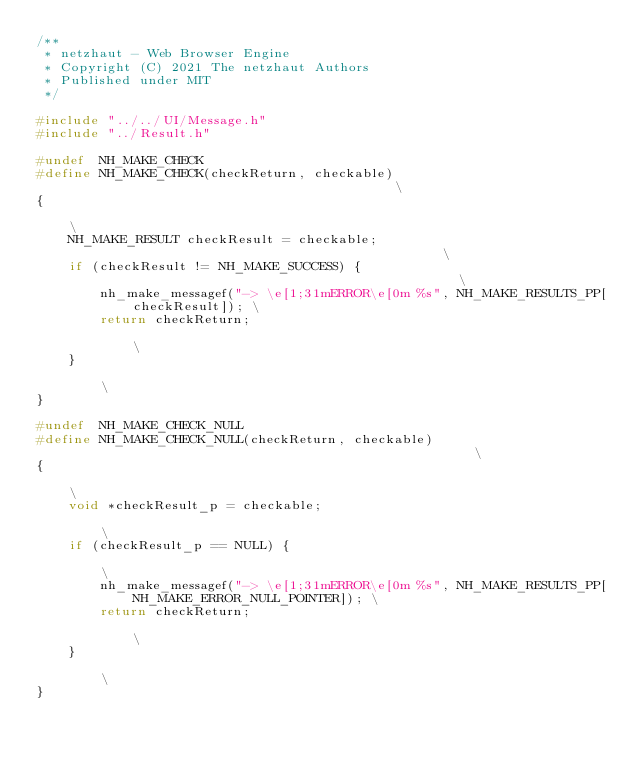Convert code to text. <code><loc_0><loc_0><loc_500><loc_500><_C_>/**
 * netzhaut - Web Browser Engine
 * Copyright (C) 2021 The netzhaut Authors
 * Published under MIT
 */

#include "../../UI/Message.h"
#include "../Result.h"

#undef  NH_MAKE_CHECK
#define NH_MAKE_CHECK(checkReturn, checkable)                                          \
{                                                                                      \
    NH_MAKE_RESULT checkResult = checkable;                                            \
    if (checkResult != NH_MAKE_SUCCESS) {                                              \
        nh_make_messagef("-> \e[1;31mERROR\e[0m %s", NH_MAKE_RESULTS_PP[checkResult]); \
        return checkReturn;                                                            \
    }                                                                                  \
}

#undef  NH_MAKE_CHECK_NULL
#define NH_MAKE_CHECK_NULL(checkReturn, checkable)                                                    \
{                                                                                                     \
    void *checkResult_p = checkable;                                                                  \
    if (checkResult_p == NULL) {                                                                      \
        nh_make_messagef("-> \e[1;31mERROR\e[0m %s", NH_MAKE_RESULTS_PP[NH_MAKE_ERROR_NULL_POINTER]); \
        return checkReturn;                                                                           \
    }                                                                                                 \
}

</code> 